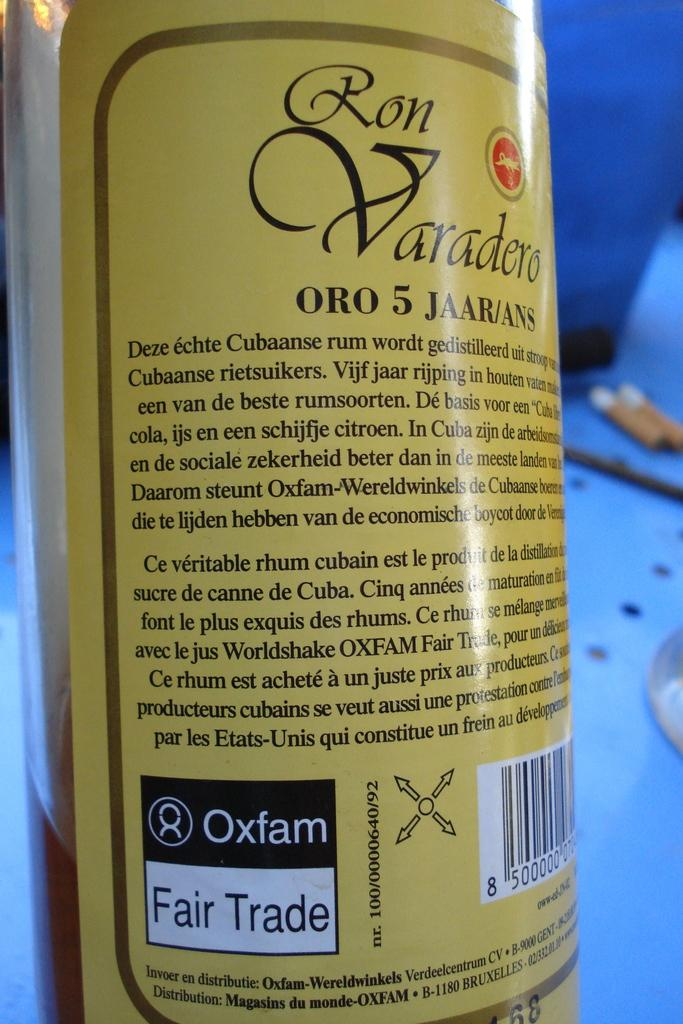<image>
Offer a succinct explanation of the picture presented. The information on the back of a Ron Varadero bottle. 